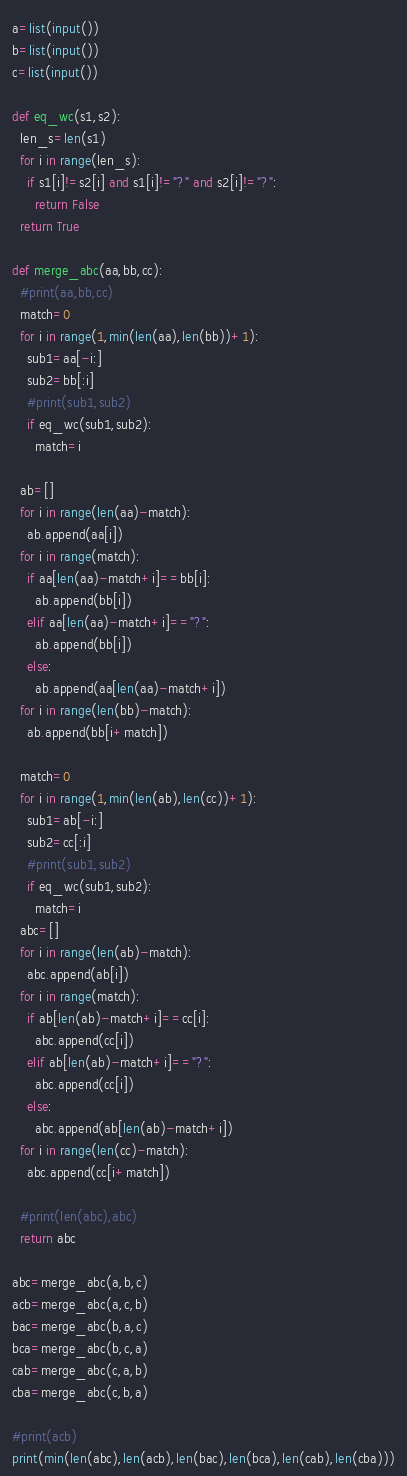<code> <loc_0><loc_0><loc_500><loc_500><_Python_>a=list(input())
b=list(input())
c=list(input())

def eq_wc(s1,s2):
  len_s=len(s1)
  for i in range(len_s):
    if s1[i]!=s2[i] and s1[i]!="?" and s2[i]!="?":
      return False
  return True

def merge_abc(aa,bb,cc):
  #print(aa,bb,cc)
  match=0
  for i in range(1,min(len(aa),len(bb))+1):
    sub1=aa[-i:]
    sub2=bb[:i]
    #print(sub1,sub2)
    if eq_wc(sub1,sub2):
      match=i

  ab=[]
  for i in range(len(aa)-match):
    ab.append(aa[i])
  for i in range(match):
    if aa[len(aa)-match+i]==bb[i]:
      ab.append(bb[i])
    elif aa[len(aa)-match+i]=="?":
      ab.append(bb[i])
    else:
      ab.append(aa[len(aa)-match+i])
  for i in range(len(bb)-match):
    ab.append(bb[i+match])  
  
  match=0
  for i in range(1,min(len(ab),len(cc))+1):
    sub1=ab[-i:]
    sub2=cc[:i]
    #print(sub1,sub2)
    if eq_wc(sub1,sub2):
      match=i
  abc=[]
  for i in range(len(ab)-match):
    abc.append(ab[i])
  for i in range(match):
    if ab[len(ab)-match+i]==cc[i]:
      abc.append(cc[i])
    elif ab[len(ab)-match+i]=="?":
      abc.append(cc[i])
    else:
      abc.append(ab[len(ab)-match+i])
  for i in range(len(cc)-match):
    abc.append(cc[i+match])
  
  #print(len(abc),abc)
  return abc

abc=merge_abc(a,b,c)
acb=merge_abc(a,c,b)
bac=merge_abc(b,a,c)
bca=merge_abc(b,c,a)
cab=merge_abc(c,a,b)
cba=merge_abc(c,b,a)

#print(acb)
print(min(len(abc),len(acb),len(bac),len(bca),len(cab),len(cba)))</code> 